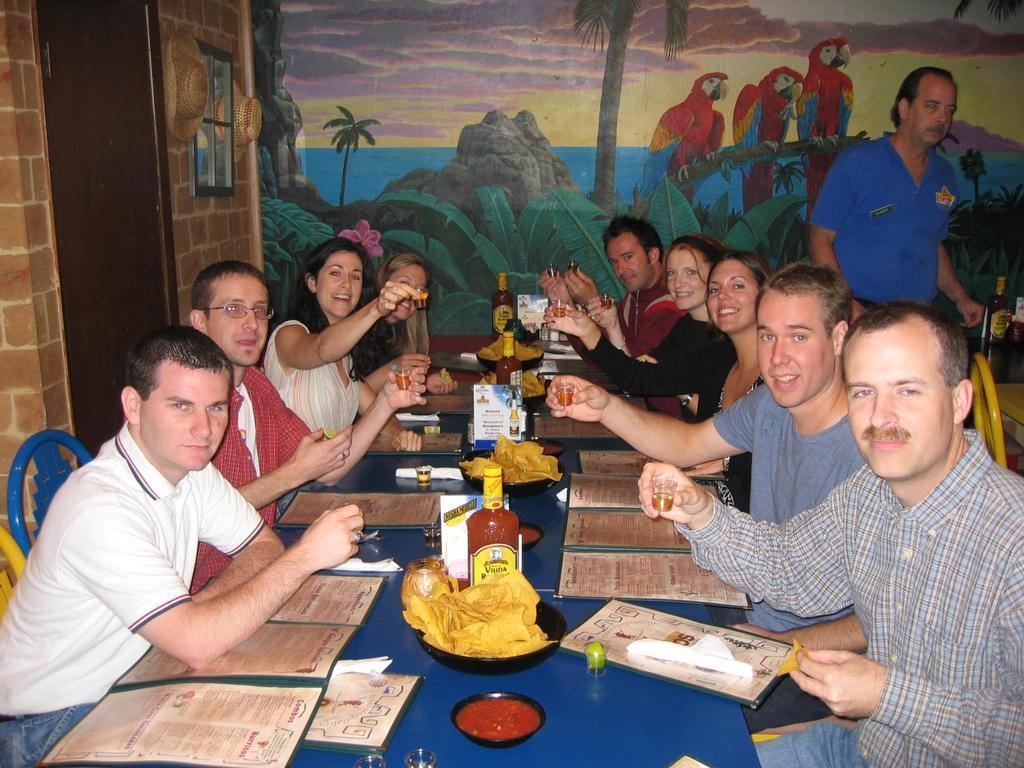Please provide a concise description of this image. There is a group of people sitting on a chair. They are having a drink and they are all smiling. Here we can see a person standing and he is on the top right side. This is a door which is on the left side. 